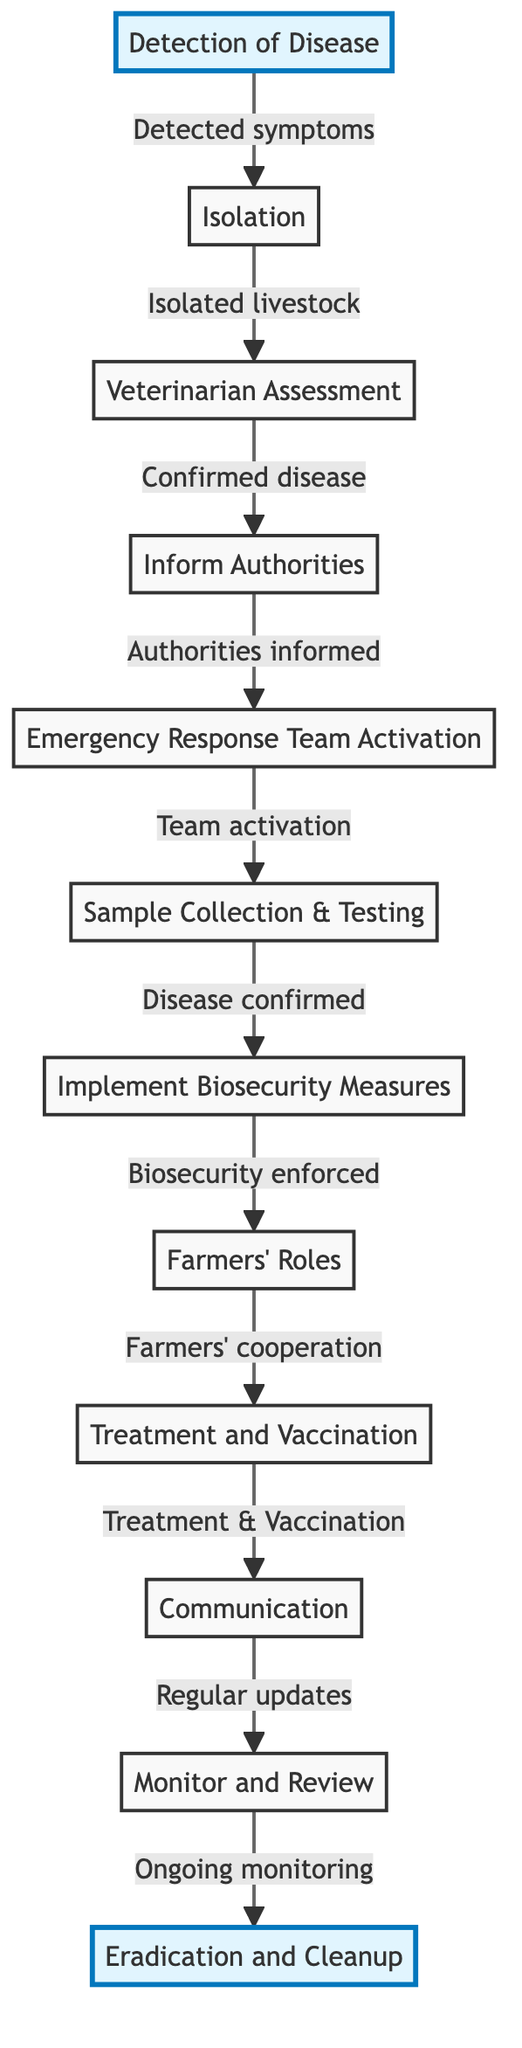What is the first step in the emergency preparedness plan? The diagram indicates that the first step is "Detection of Disease," which is also highlighted for emphasis.
Answer: Detection of Disease What do you do after isolating livestock? According to the flowchart, after isolation, the next step is "Veterinarian Assessment."
Answer: Veterinarian Assessment How many steps are involved in the plan? By counting the numbered nodes in the flowchart, there are 12 steps in total.
Answer: 12 Which step follows "Inform Authorities"? The flowchart shows that the step that follows "Inform Authorities" is "Emergency Response Team Activation."
Answer: Emergency Response Team Activation What is the role of farmers in this plan? The diagram states that farmers are responsible for "Farmers' Roles," which is a critical part of the sequence after biosecurity measures.
Answer: Farmers' Roles How many nodes are highlighted in the diagram? By reviewing the diagram, there are 2 highlighted nodes: "Detection of Disease" and "Eradication and Cleanup."
Answer: 2 What comes before "Treatment and Vaccination"? The flowchart demonstrates that "Farmers' Roles" comes before "Treatment and Vaccination."
Answer: Farmers' Roles What is the last step in the flowchart? The final step listed in the diagram is "Eradication and Cleanup," which is highlighted to signify its importance.
Answer: Eradication and Cleanup What is required after sample collection and testing? The next action after "Sample Collection & Testing" according to the diagram is "Implement Biosecurity Measures."
Answer: Implement Biosecurity Measures 